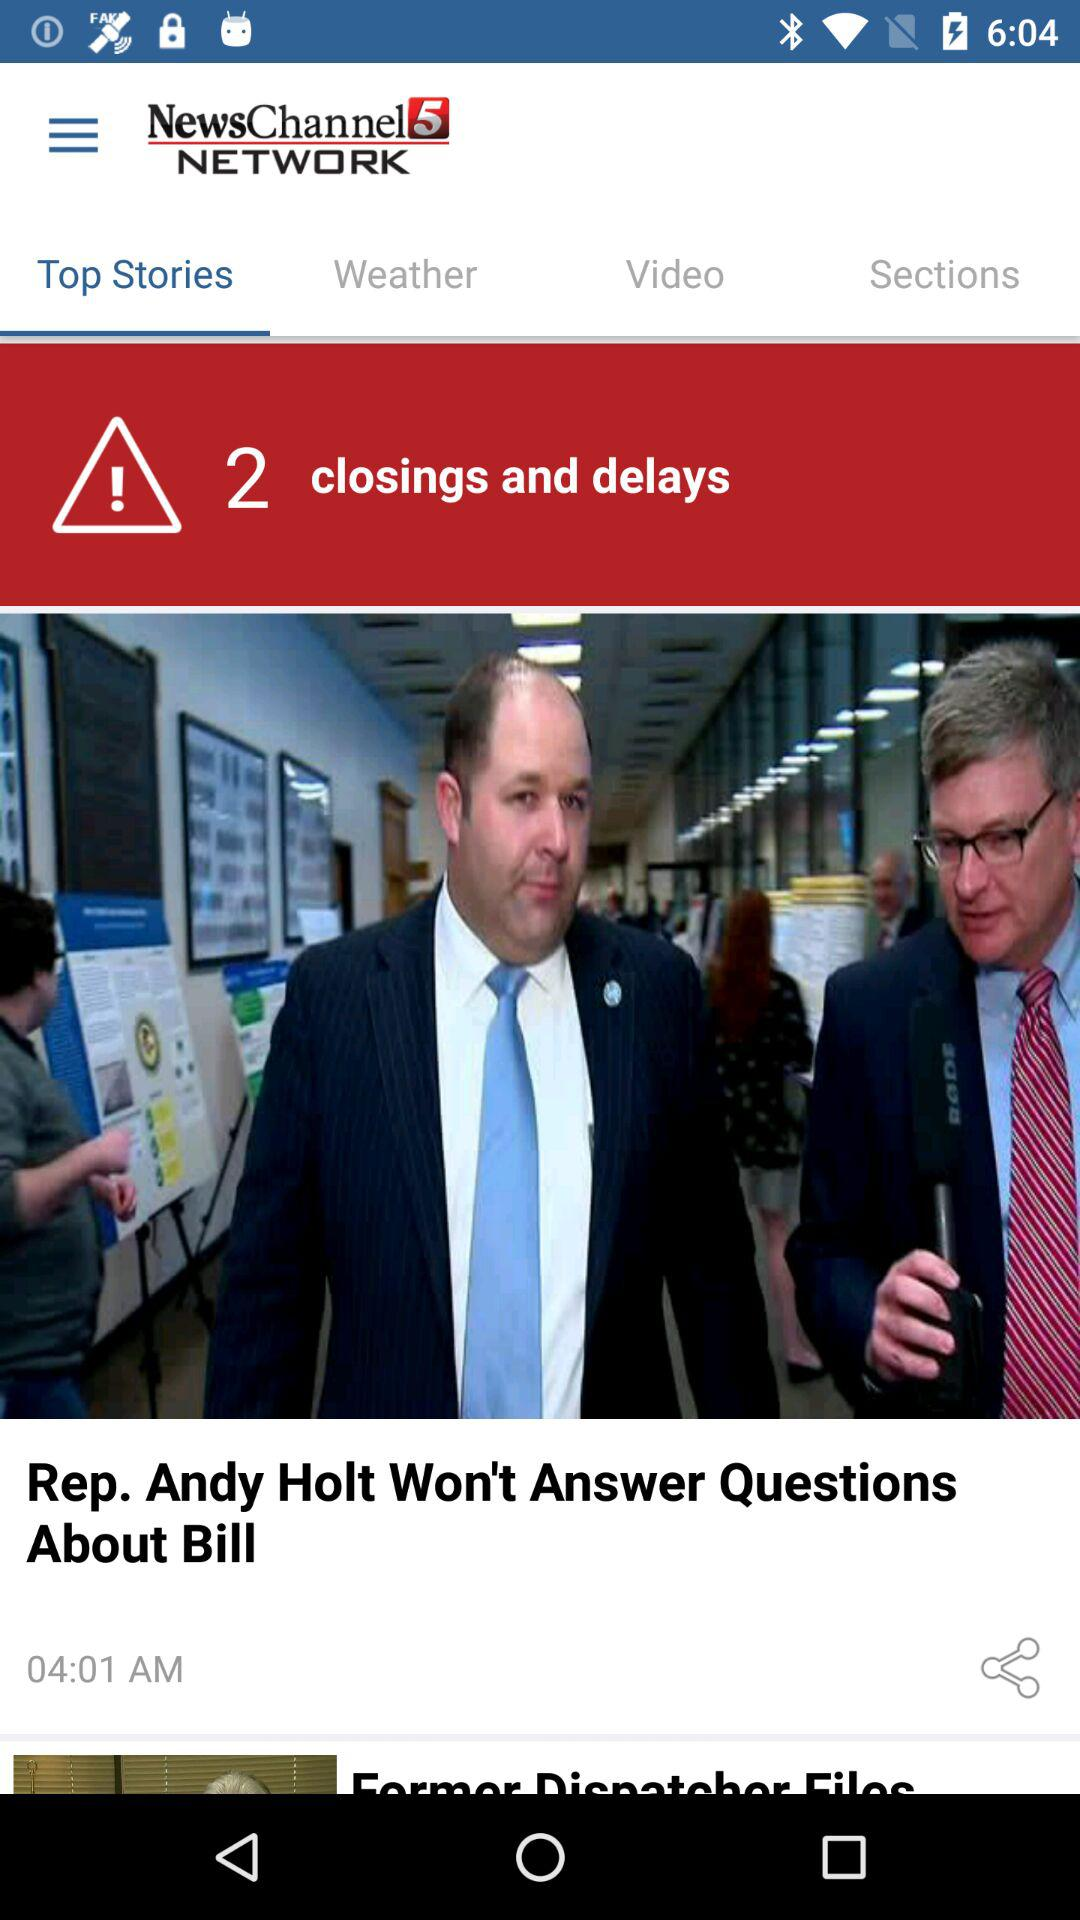How will the weather be in the morning?
When the provided information is insufficient, respond with <no answer>. <no answer> 